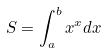<formula> <loc_0><loc_0><loc_500><loc_500>S = \int _ { a } ^ { b } x ^ { x } d x</formula> 